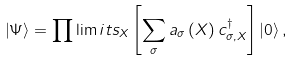<formula> <loc_0><loc_0><loc_500><loc_500>\left | \Psi \right \rangle = \prod \lim i t s _ { X } \left [ \sum _ { \sigma } a _ { \sigma } \left ( X \right ) c _ { \sigma , X } ^ { \dag } \right ] \left | 0 \right \rangle ,</formula> 